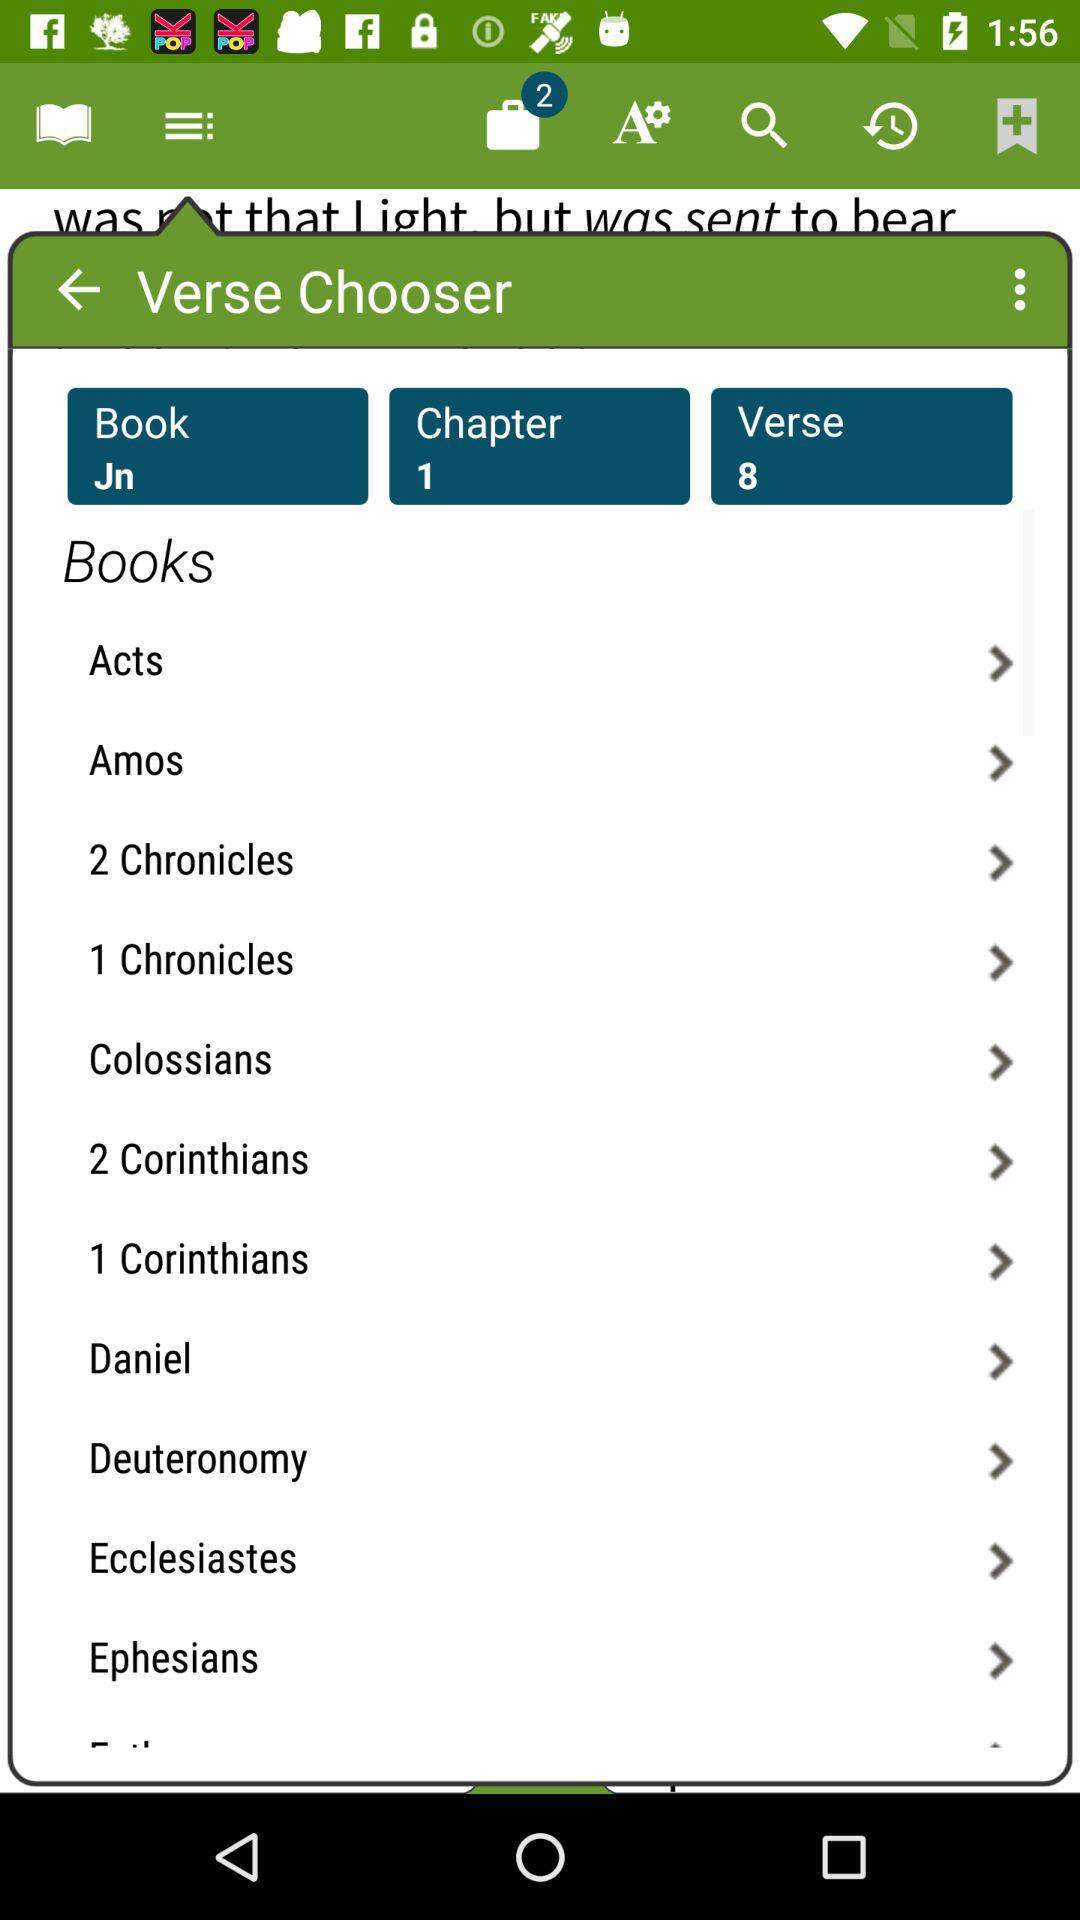What's the total number of verses? The total number of verses is 8. 